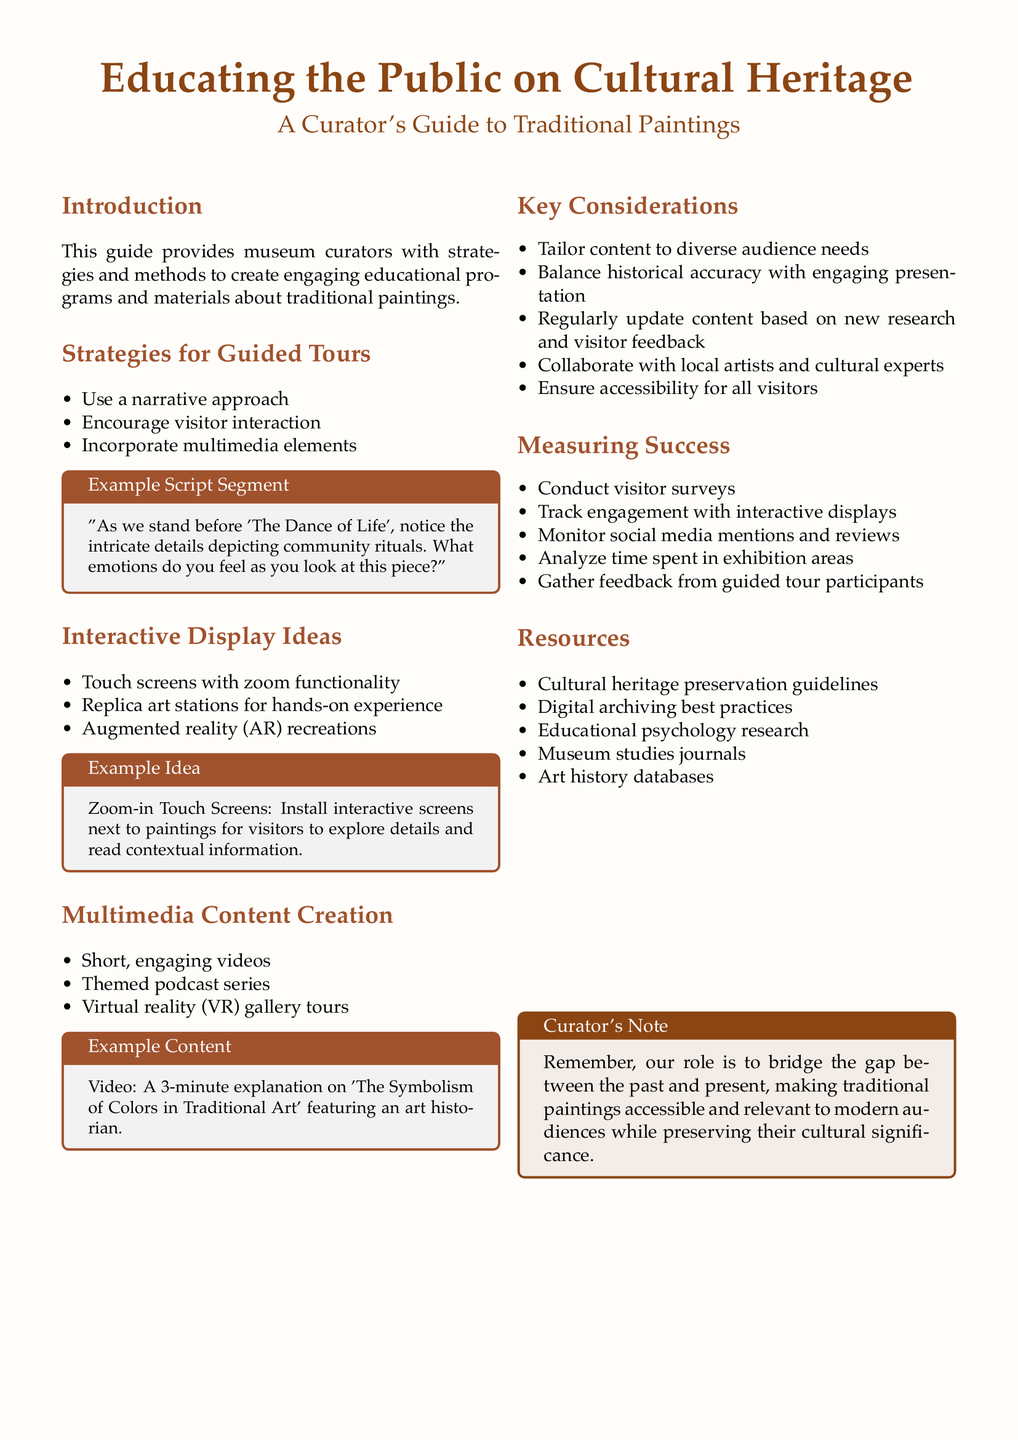What is the title of the guide? The title of the guide is prominently displayed at the beginning of the document.
Answer: Educating the Public on Cultural Heritage What are two strategies for guided tours? The document lists several strategies for guided tours, and the question requires identifying two of them.
Answer: Use a narrative approach, Encourage visitor interaction What type of interactive display is suggested for hands-on experience? The document mentions different interactive display ideas, and this question focuses on one specific type.
Answer: Replica art stations What is one example of multimedia content mentioned? The document provides multiple examples of multimedia content creation and seeks a specific instance.
Answer: Short, engaging videos What is a key consideration related to audience? The key considerations section highlights various important aspects, with one directly addressing the audience needs.
Answer: Tailor content to diverse audience needs How can success be measured, according to the document? The document outlines various ways to measure the success of educational programs, leading to a straightforward inquiry.
Answer: Conduct visitor surveys What is the color scheme used for the title? The document specifies the color for the title, allowing for a direct retrieval of a specific design choice.
Answer: RGB (139,69,19) What is the purpose of the Curator's Note? The Curator's Note section provides insights into the guide's intent, which can be inferred from its content.
Answer: Bridge the gap between the past and present What type of research resources are included? The document lists resources related to cultural heritage and educational practices, relevant to curators.
Answer: Educational psychology research 